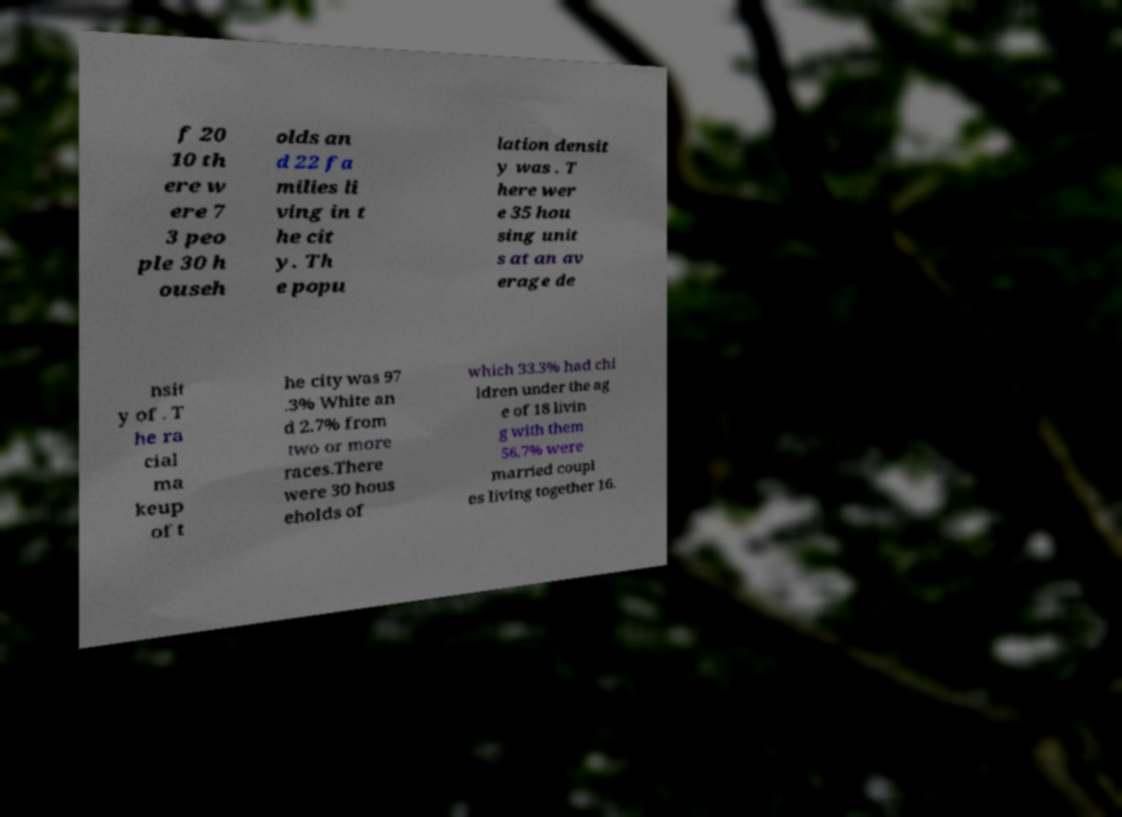Please read and relay the text visible in this image. What does it say? f 20 10 th ere w ere 7 3 peo ple 30 h ouseh olds an d 22 fa milies li ving in t he cit y. Th e popu lation densit y was . T here wer e 35 hou sing unit s at an av erage de nsit y of . T he ra cial ma keup of t he city was 97 .3% White an d 2.7% from two or more races.There were 30 hous eholds of which 33.3% had chi ldren under the ag e of 18 livin g with them 56.7% were married coupl es living together 16. 